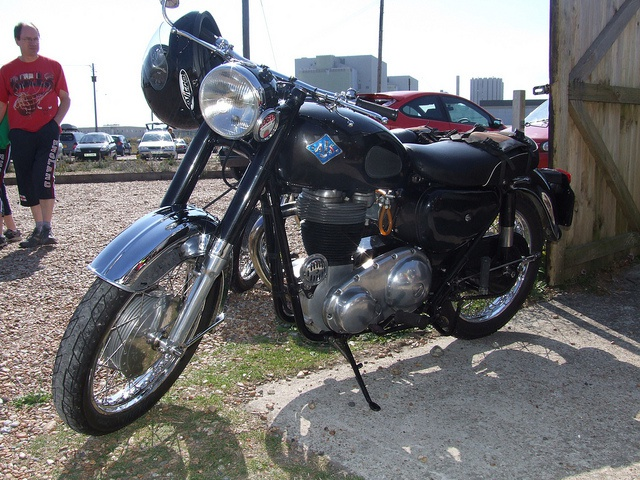Describe the objects in this image and their specific colors. I can see motorcycle in white, black, gray, and darkgray tones, people in white, black, maroon, and gray tones, car in white, brown, navy, black, and gray tones, car in white, lavender, maroon, black, and pink tones, and car in white, black, lavender, and gray tones in this image. 